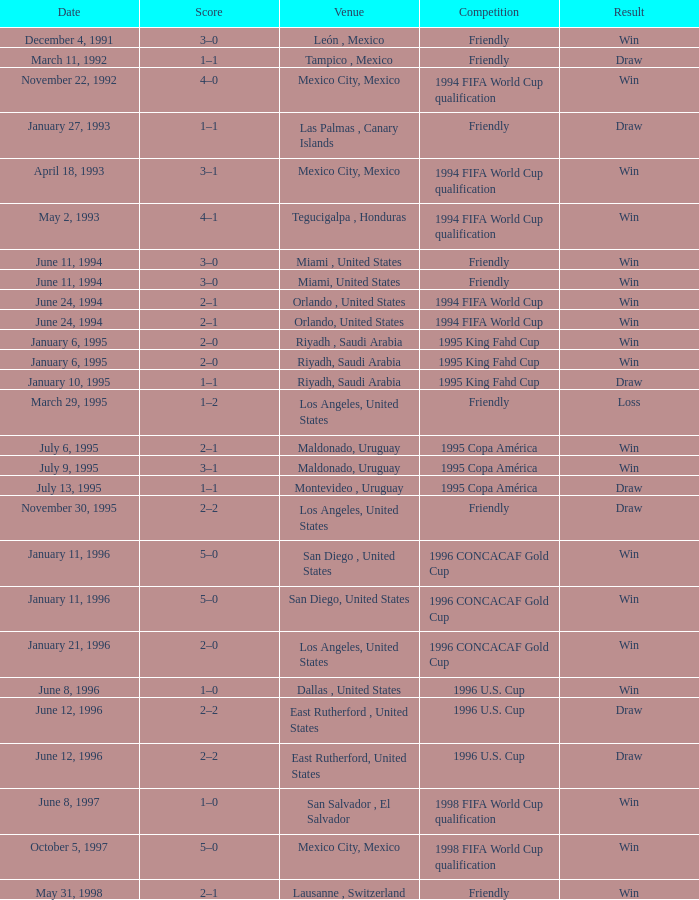What is Venue, when Date is "January 6, 1995"? Riyadh , Saudi Arabia, Riyadh, Saudi Arabia. 